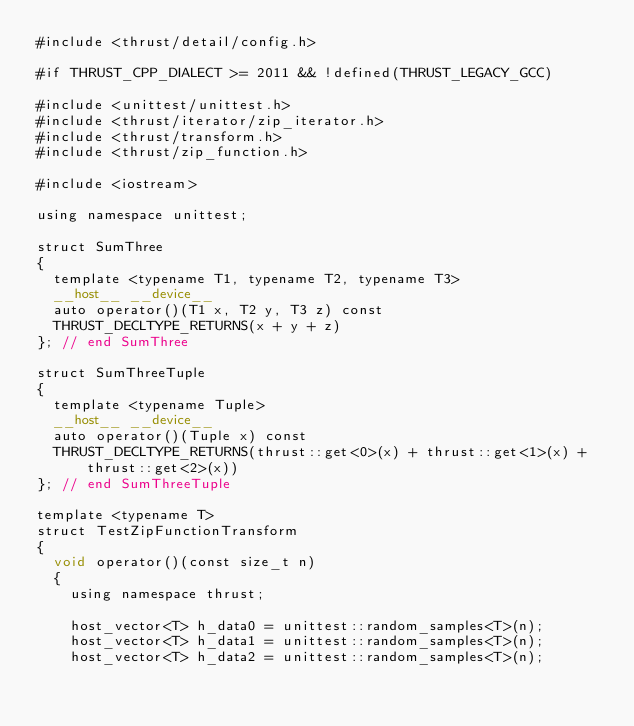<code> <loc_0><loc_0><loc_500><loc_500><_Cuda_>#include <thrust/detail/config.h>

#if THRUST_CPP_DIALECT >= 2011 && !defined(THRUST_LEGACY_GCC)

#include <unittest/unittest.h>
#include <thrust/iterator/zip_iterator.h>
#include <thrust/transform.h>
#include <thrust/zip_function.h>

#include <iostream>

using namespace unittest;

struct SumThree
{
  template <typename T1, typename T2, typename T3>
  __host__ __device__
  auto operator()(T1 x, T2 y, T3 z) const
  THRUST_DECLTYPE_RETURNS(x + y + z)
}; // end SumThree

struct SumThreeTuple
{
  template <typename Tuple>
  __host__ __device__
  auto operator()(Tuple x) const
  THRUST_DECLTYPE_RETURNS(thrust::get<0>(x) + thrust::get<1>(x) + thrust::get<2>(x))
}; // end SumThreeTuple

template <typename T>
struct TestZipFunctionTransform
{
  void operator()(const size_t n)
  {
    using namespace thrust;

    host_vector<T> h_data0 = unittest::random_samples<T>(n);
    host_vector<T> h_data1 = unittest::random_samples<T>(n);
    host_vector<T> h_data2 = unittest::random_samples<T>(n);
</code> 